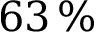<formula> <loc_0><loc_0><loc_500><loc_500>6 3 \, \%</formula> 